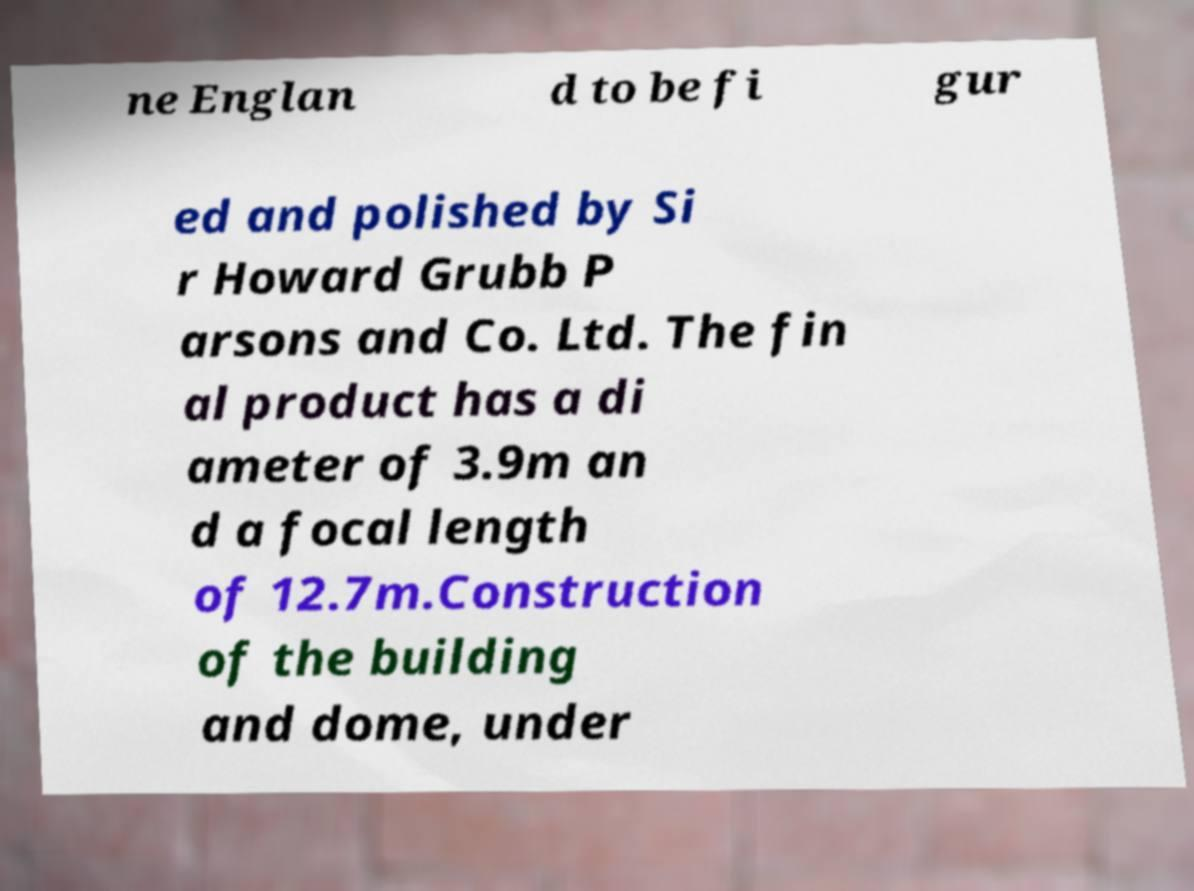What messages or text are displayed in this image? I need them in a readable, typed format. ne Englan d to be fi gur ed and polished by Si r Howard Grubb P arsons and Co. Ltd. The fin al product has a di ameter of 3.9m an d a focal length of 12.7m.Construction of the building and dome, under 